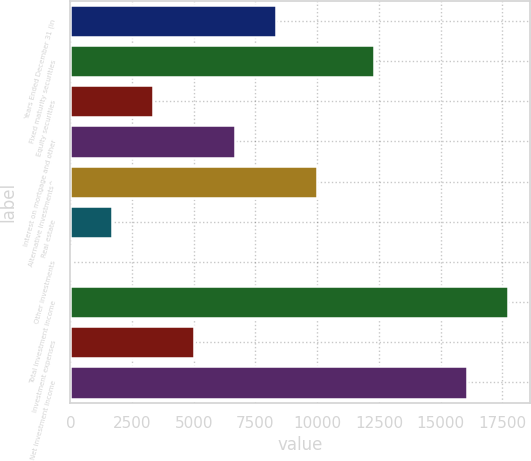Convert chart to OTSL. <chart><loc_0><loc_0><loc_500><loc_500><bar_chart><fcel>Years Ended December 31 (in<fcel>Fixed maturity securities<fcel>Equity securities<fcel>Interest on mortgage and other<fcel>Alternative investments^<fcel>Real estate<fcel>Other investments<fcel>Total investment income<fcel>Investment expenses<fcel>Net investment income<nl><fcel>8321.5<fcel>12322<fcel>3356.8<fcel>6666.6<fcel>9976.4<fcel>1701.9<fcel>47<fcel>17733.9<fcel>5011.7<fcel>16079<nl></chart> 